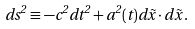<formula> <loc_0><loc_0><loc_500><loc_500>d s ^ { 2 } \equiv - c ^ { 2 } d t ^ { 2 } + a ^ { 2 } ( t ) d \vec { x } \cdot d \vec { x } \, .</formula> 